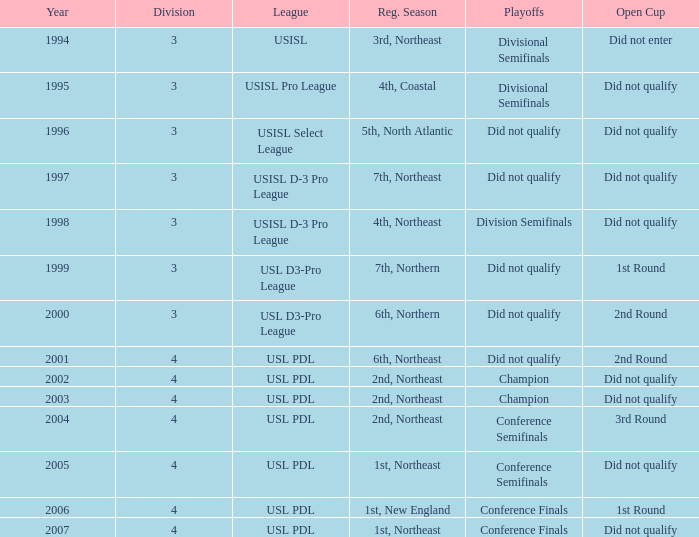Write the full table. {'header': ['Year', 'Division', 'League', 'Reg. Season', 'Playoffs', 'Open Cup'], 'rows': [['1994', '3', 'USISL', '3rd, Northeast', 'Divisional Semifinals', 'Did not enter'], ['1995', '3', 'USISL Pro League', '4th, Coastal', 'Divisional Semifinals', 'Did not qualify'], ['1996', '3', 'USISL Select League', '5th, North Atlantic', 'Did not qualify', 'Did not qualify'], ['1997', '3', 'USISL D-3 Pro League', '7th, Northeast', 'Did not qualify', 'Did not qualify'], ['1998', '3', 'USISL D-3 Pro League', '4th, Northeast', 'Division Semifinals', 'Did not qualify'], ['1999', '3', 'USL D3-Pro League', '7th, Northern', 'Did not qualify', '1st Round'], ['2000', '3', 'USL D3-Pro League', '6th, Northern', 'Did not qualify', '2nd Round'], ['2001', '4', 'USL PDL', '6th, Northeast', 'Did not qualify', '2nd Round'], ['2002', '4', 'USL PDL', '2nd, Northeast', 'Champion', 'Did not qualify'], ['2003', '4', 'USL PDL', '2nd, Northeast', 'Champion', 'Did not qualify'], ['2004', '4', 'USL PDL', '2nd, Northeast', 'Conference Semifinals', '3rd Round'], ['2005', '4', 'USL PDL', '1st, Northeast', 'Conference Semifinals', 'Did not qualify'], ['2006', '4', 'USL PDL', '1st, New England', 'Conference Finals', '1st Round'], ['2007', '4', 'USL PDL', '1st, Northeast', 'Conference Finals', 'Did not qualify']]} What playoffs are associated with the usisl select league? Did not qualify. 